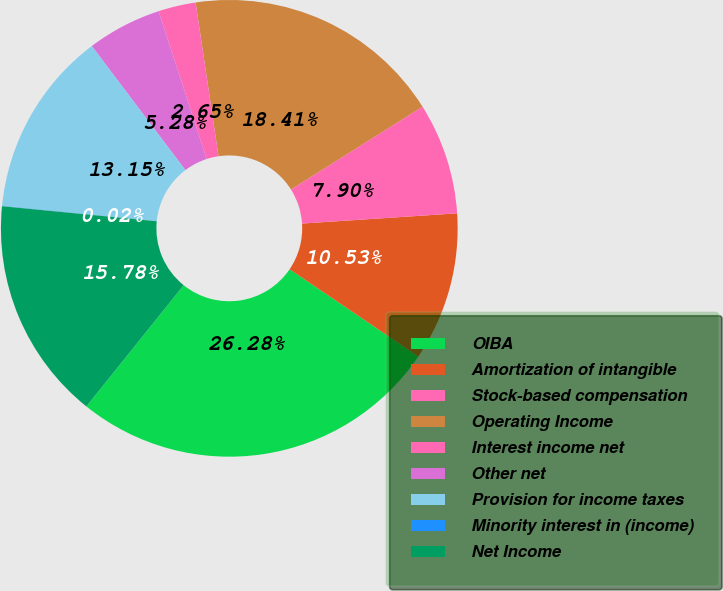Convert chart. <chart><loc_0><loc_0><loc_500><loc_500><pie_chart><fcel>OIBA<fcel>Amortization of intangible<fcel>Stock-based compensation<fcel>Operating Income<fcel>Interest income net<fcel>Other net<fcel>Provision for income taxes<fcel>Minority interest in (income)<fcel>Net Income<nl><fcel>26.28%<fcel>10.53%<fcel>7.9%<fcel>18.41%<fcel>2.65%<fcel>5.28%<fcel>13.15%<fcel>0.02%<fcel>15.78%<nl></chart> 